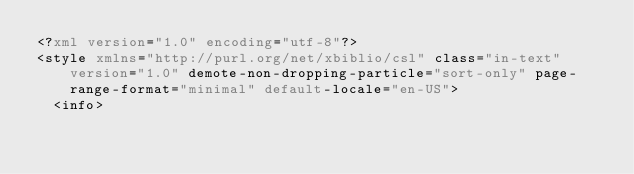<code> <loc_0><loc_0><loc_500><loc_500><_XML_><?xml version="1.0" encoding="utf-8"?>
<style xmlns="http://purl.org/net/xbiblio/csl" class="in-text" version="1.0" demote-non-dropping-particle="sort-only" page-range-format="minimal" default-locale="en-US">
  <info></code> 